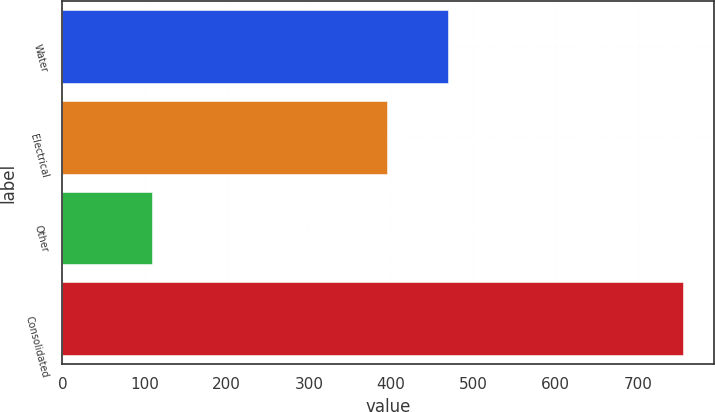Convert chart to OTSL. <chart><loc_0><loc_0><loc_500><loc_500><bar_chart><fcel>Water<fcel>Electrical<fcel>Other<fcel>Consolidated<nl><fcel>469<fcel>395<fcel>108.8<fcel>755.2<nl></chart> 